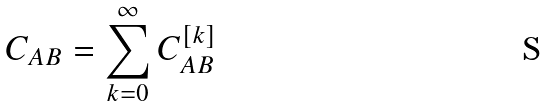Convert formula to latex. <formula><loc_0><loc_0><loc_500><loc_500>C _ { A B } = \sum _ { k = 0 } ^ { \infty } C _ { A B } ^ { [ k ] }</formula> 